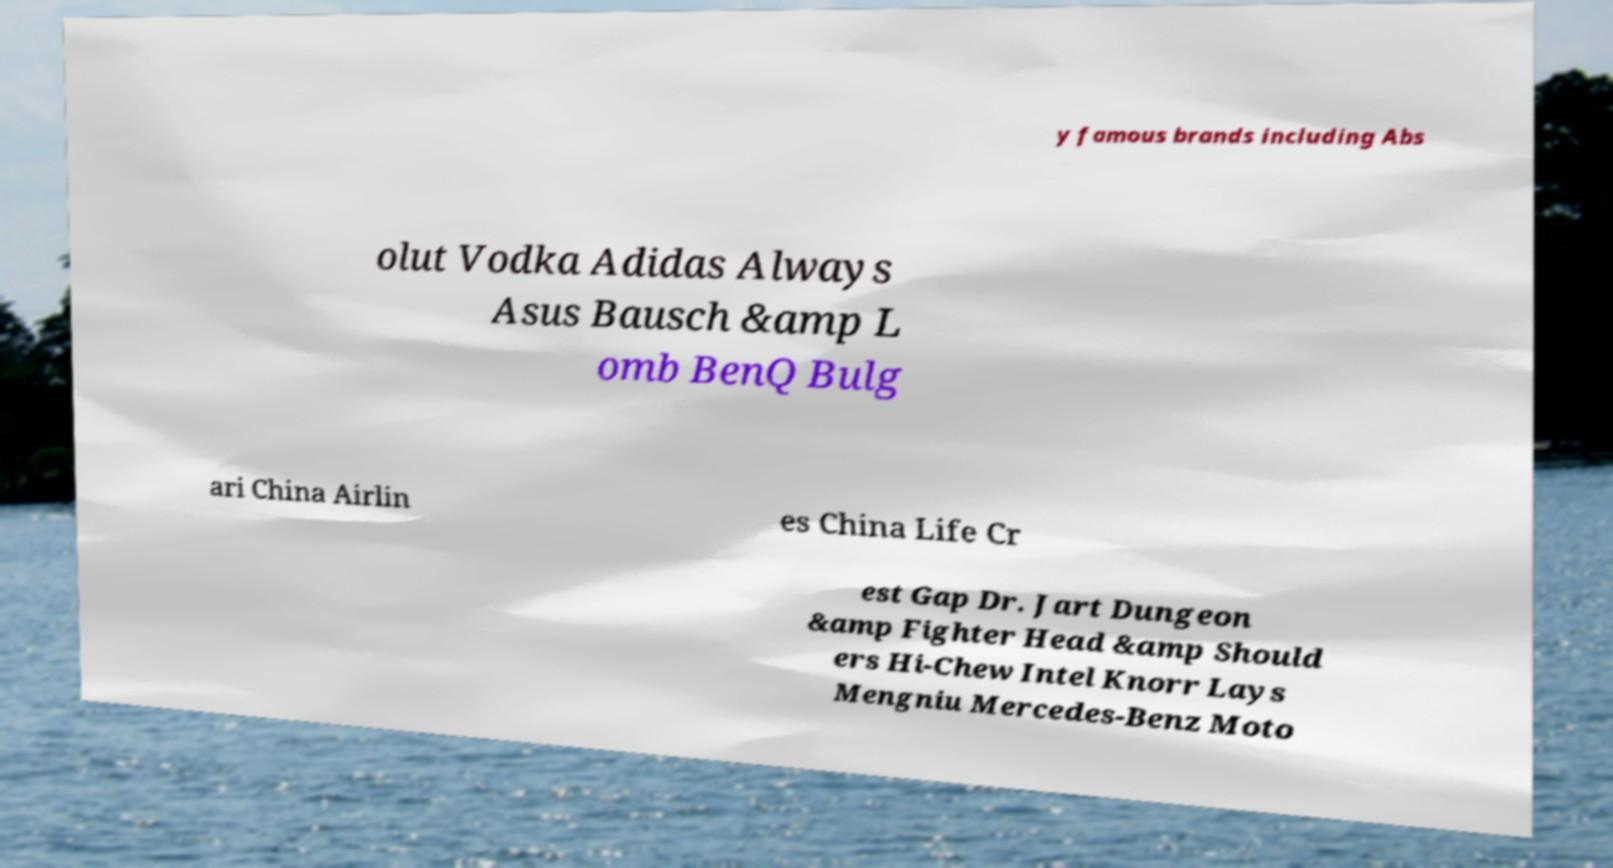Could you extract and type out the text from this image? y famous brands including Abs olut Vodka Adidas Always Asus Bausch &amp L omb BenQ Bulg ari China Airlin es China Life Cr est Gap Dr. Jart Dungeon &amp Fighter Head &amp Should ers Hi-Chew Intel Knorr Lays Mengniu Mercedes-Benz Moto 